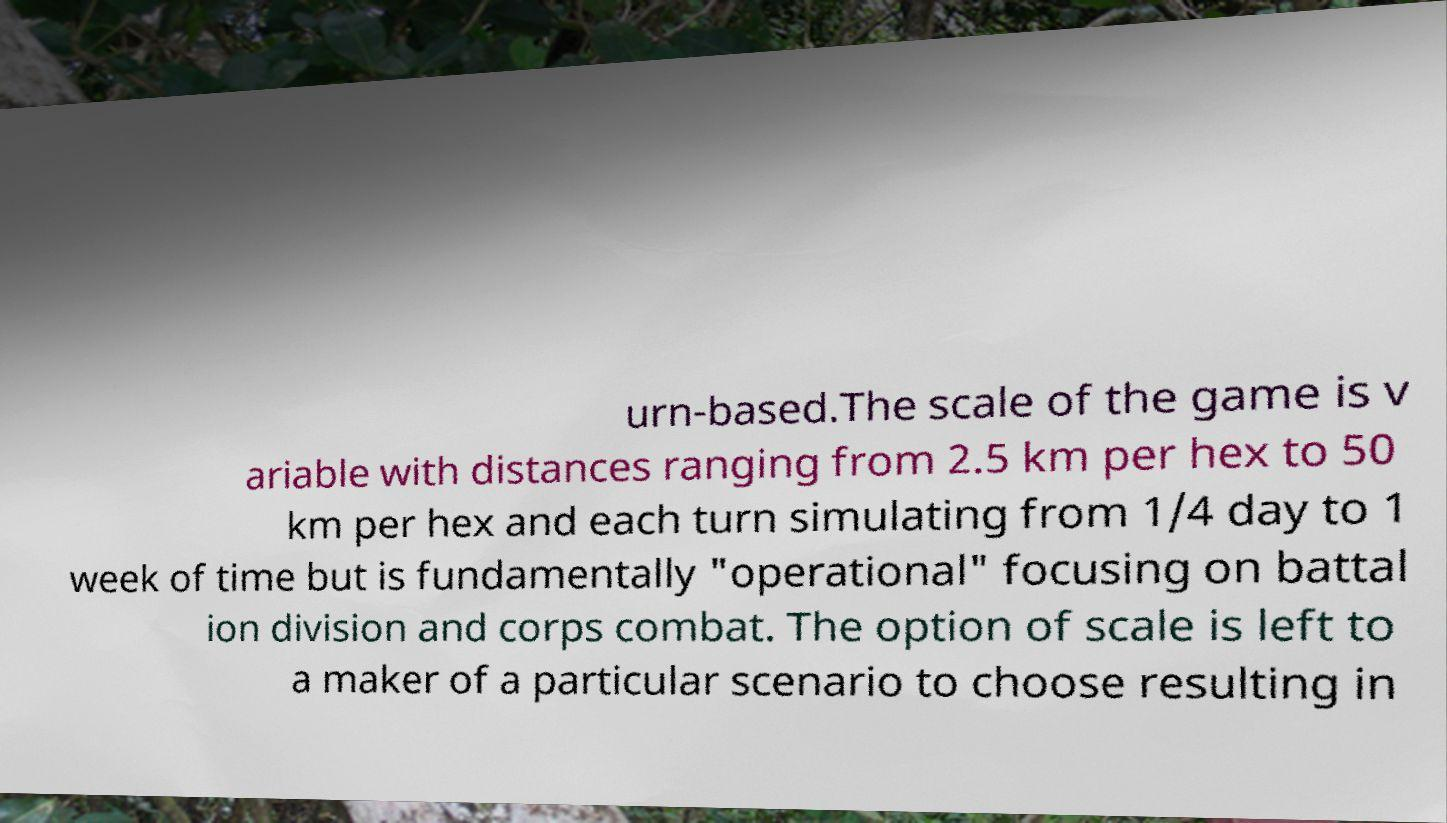Please read and relay the text visible in this image. What does it say? urn-based.The scale of the game is v ariable with distances ranging from 2.5 km per hex to 50 km per hex and each turn simulating from 1/4 day to 1 week of time but is fundamentally "operational" focusing on battal ion division and corps combat. The option of scale is left to a maker of a particular scenario to choose resulting in 